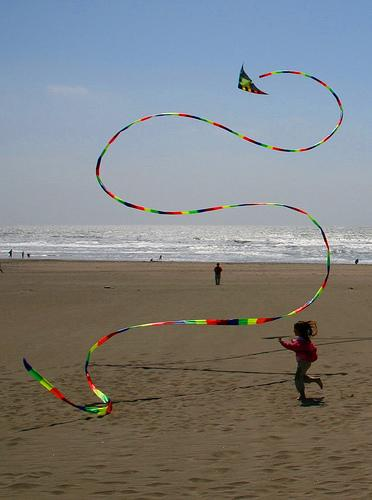What are the different colors of the kite in the image? Green, red, orange, blue, yellow, pink, purple, and multicolor. How many footprints can be observed in the sand on the beach? There are two sets of footprints in the sand, one along the shoreline and another further inland. Describe the appearance of the sky in the image, including any notable features. The sky is blue and clear, with white clouds scattered around in various shapes and sizes. Are there any people in the water? If yes, how many and what are they doing? Yes, there are people in the water. There are two groups: one with three people and another with two people. They are playing on the shoreline. Mention the colors and any recognizable theme present in the little girl's clothing. The little girl is wearing a pink jacket, pink and purple shirt, and has a multicolored kite. Identify the activities taking place on the beach in the image. Footprints in the sand, child running, smooth sand, person standing and looking at the water, kite flying, people playing on the shore, girl running and flying a kite, man walking, wave interactions, and kite tail touching the sand. What is the overall sentiment conveyed by the image? A joyful and carefree day at the beach, with people enjoying the sun, sand, and water. Explain any complex reasoning happening in the image. People of various ages are enjoying the beach, with children playing and flying kites, indicating a family-friendly environment. The footprints in the sand and smoothness suggest frequent human activity, and clear skies with scattered clouds emphasize a picturesque beach scene. Describe the quality of the sand on the beach in the image. The sand on the beach is light brown, smooth, and has visible footprints. 